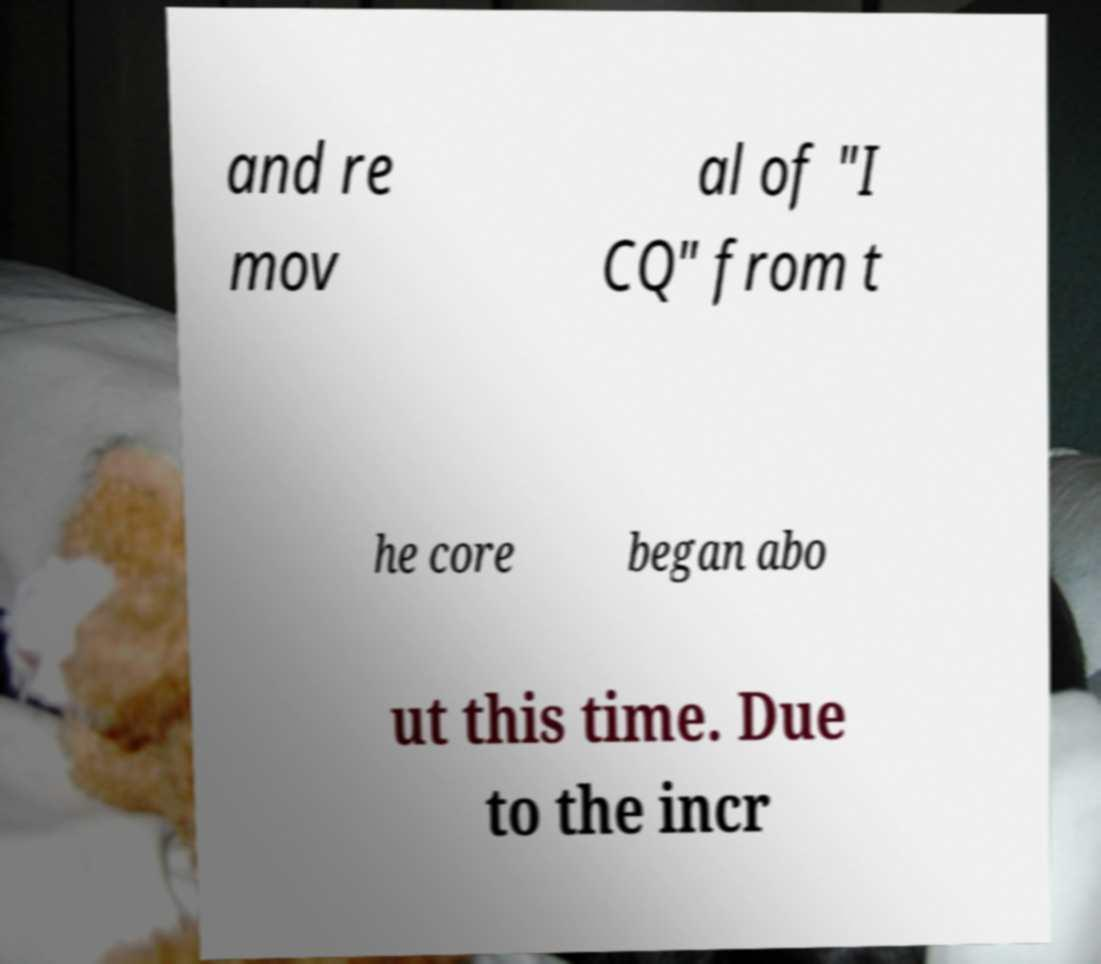Can you read and provide the text displayed in the image?This photo seems to have some interesting text. Can you extract and type it out for me? and re mov al of "I CQ" from t he core began abo ut this time. Due to the incr 